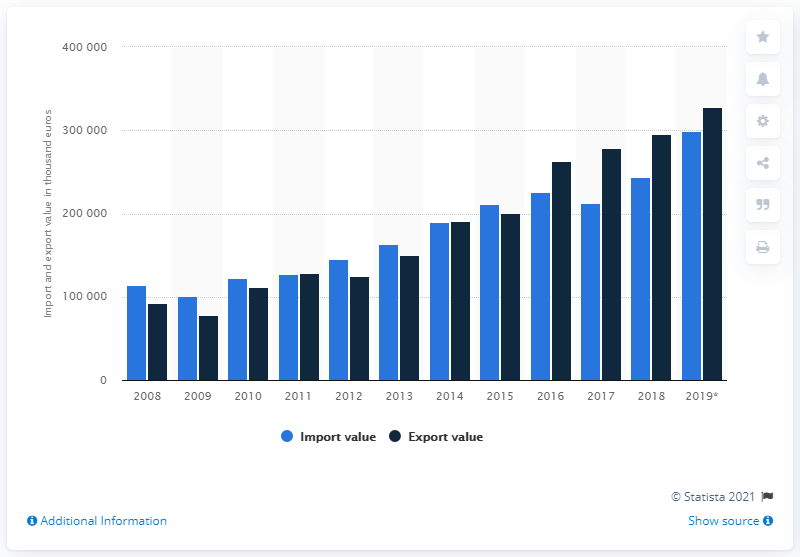List a handful of essential elements in this visual. In 2008, the import and export of guavas, mangoes, and mangosteens began. 